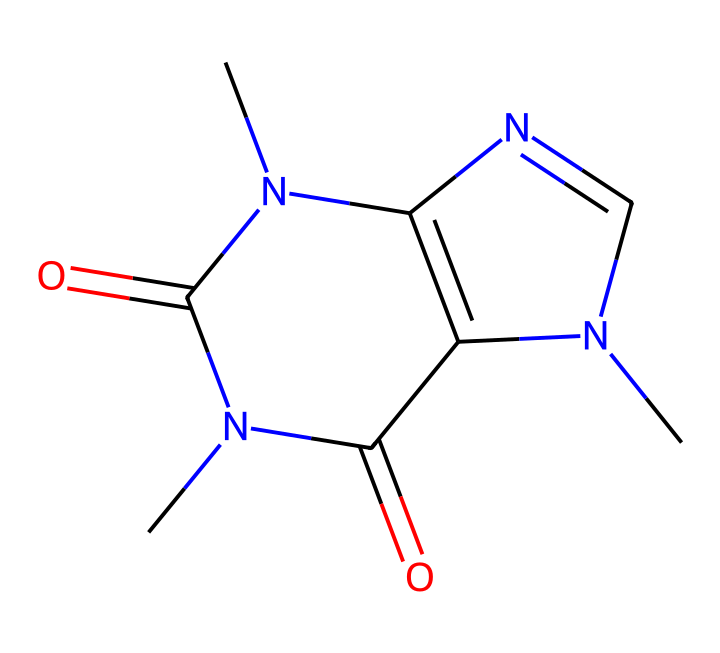What is the molecular formula of caffeine? The SMILES representation encodes the molecular structure of caffeine, which includes specific atoms: carbon (C), hydrogen (H), nitrogen (N), and oxygen (O). By counting the instances of each atom, we derive the molecular formula C8H10N4O2.
Answer: C8H10N4O2 How many nitrogen atoms are present in caffeine? By examining the SMILES representation, the presence of nitrogen atoms can be identified. There are four nitrogen atoms (N) in the structure of caffeine.
Answer: 4 What is the total number of rings in the structure of caffeine? The structure contains three interconnected rings as indicated by the presence of double bonds and nitrogen atoms in cyclic arrangements in the SMILES notation.
Answer: 3 Does caffeine contain any double bonds? The structure shows alternating connections between atoms in specific sections of the molecule, indicating the presence of double bonds between carbon and nitrogen.
Answer: Yes What type of compound is caffeine classified as? Caffeine is classified as an alkaloid, which is a type of nitrogen-containing compound often derived from plants. This classification is evident from the presence of nitrogen in its structure.
Answer: alkaloid What functional groups are present in caffeine? The caffeine structure contains two carbonyl (C=O) groups, which are typical functional groups in many organic compounds, including some that exhibit stimulant properties.
Answer: carbonyl groups What characteristic of caffeine contributes to its stimulating effects? The structure of caffeine contains three methyl groups attached to nitrogen atoms; this methylation is an essential feature that contributes to its stimulant properties.
Answer: methyl groups 